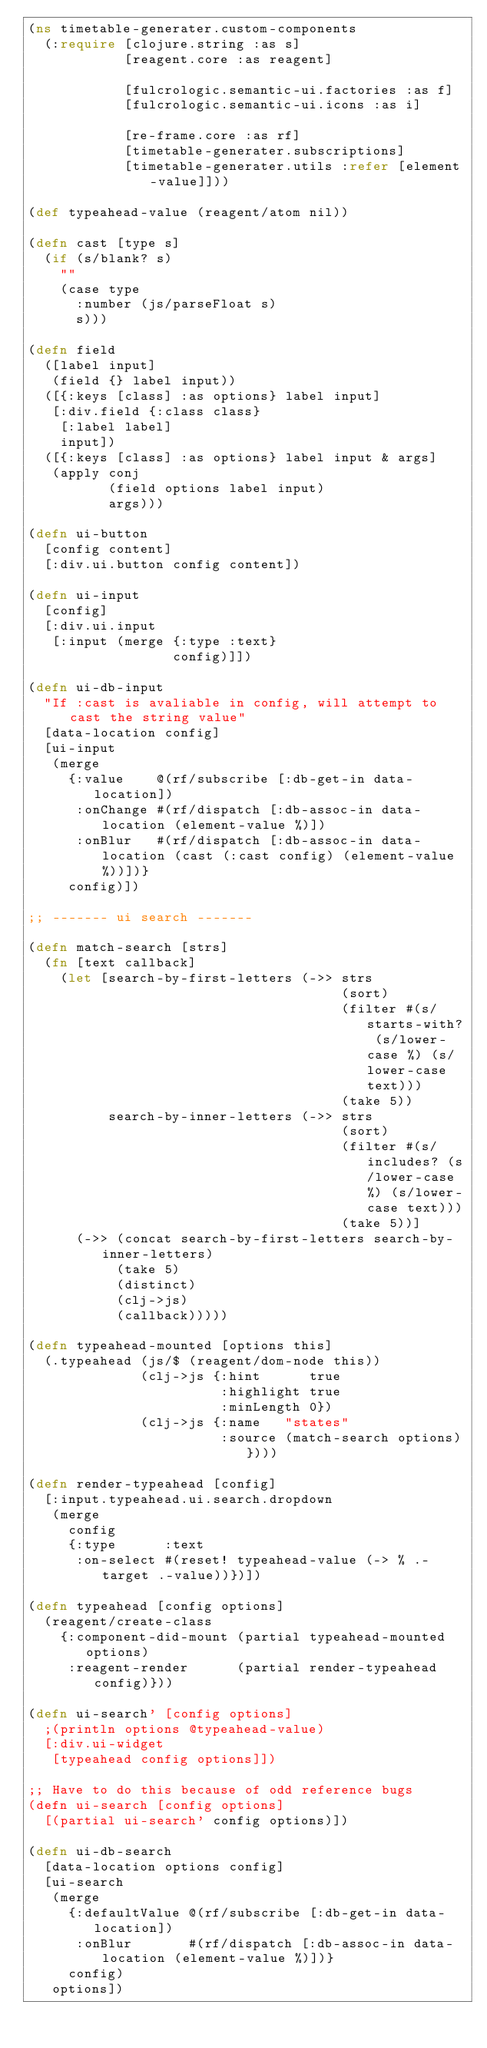<code> <loc_0><loc_0><loc_500><loc_500><_Clojure_>(ns timetable-generater.custom-components
  (:require [clojure.string :as s]
            [reagent.core :as reagent]

            [fulcrologic.semantic-ui.factories :as f]
            [fulcrologic.semantic-ui.icons :as i]

            [re-frame.core :as rf]
            [timetable-generater.subscriptions]
            [timetable-generater.utils :refer [element-value]]))

(def typeahead-value (reagent/atom nil))

(defn cast [type s]
  (if (s/blank? s)
    ""
    (case type
      :number (js/parseFloat s)
      s)))

(defn field
  ([label input]
   (field {} label input))
  ([{:keys [class] :as options} label input]
   [:div.field {:class class}
    [:label label]
    input])
  ([{:keys [class] :as options} label input & args]
   (apply conj
          (field options label input)
          args)))

(defn ui-button
  [config content]
  [:div.ui.button config content])

(defn ui-input
  [config]
  [:div.ui.input
   [:input (merge {:type :text}
                  config)]])

(defn ui-db-input
  "If :cast is avaliable in config, will attempt to cast the string value"
  [data-location config]
  [ui-input
   (merge
     {:value    @(rf/subscribe [:db-get-in data-location])
      :onChange #(rf/dispatch [:db-assoc-in data-location (element-value %)])
      :onBlur   #(rf/dispatch [:db-assoc-in data-location (cast (:cast config) (element-value %))])}
     config)])

;; ------- ui search -------

(defn match-search [strs]
  (fn [text callback]
    (let [search-by-first-letters (->> strs
                                       (sort)
                                       (filter #(s/starts-with? (s/lower-case %) (s/lower-case text)))
                                       (take 5))
          search-by-inner-letters (->> strs
                                       (sort)
                                       (filter #(s/includes? (s/lower-case %) (s/lower-case text)))
                                       (take 5))]
      (->> (concat search-by-first-letters search-by-inner-letters)
           (take 5)
           (distinct)
           (clj->js)
           (callback)))))

(defn typeahead-mounted [options this]
  (.typeahead (js/$ (reagent/dom-node this))
              (clj->js {:hint      true
                        :highlight true
                        :minLength 0})
              (clj->js {:name   "states"
                        :source (match-search options)})))

(defn render-typeahead [config]
  [:input.typeahead.ui.search.dropdown
   (merge
     config
     {:type      :text
      :on-select #(reset! typeahead-value (-> % .-target .-value))})])

(defn typeahead [config options]
  (reagent/create-class
    {:component-did-mount (partial typeahead-mounted options)
     :reagent-render      (partial render-typeahead config)}))

(defn ui-search' [config options]
  ;(println options @typeahead-value)
  [:div.ui-widget
   [typeahead config options]])

;; Have to do this because of odd reference bugs
(defn ui-search [config options]
  [(partial ui-search' config options)])

(defn ui-db-search
  [data-location options config]
  [ui-search
   (merge
     {:defaultValue @(rf/subscribe [:db-get-in data-location])
      :onBlur       #(rf/dispatch [:db-assoc-in data-location (element-value %)])}
     config)
   options])
</code> 